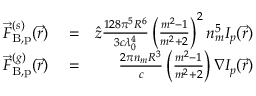<formula> <loc_0><loc_0><loc_500><loc_500>\begin{array} { r l r } { \vec { F } _ { B , p } ^ { ( s ) } ( \vec { r } ) } & = } & { \hat { z } \frac { 1 2 8 \pi ^ { 5 } R ^ { 6 } } { 3 c \lambda _ { 0 } ^ { 4 } } \left ( \frac { m ^ { 2 } - 1 } { m ^ { 2 } + 2 } \right ) ^ { 2 } n _ { m } ^ { 5 } I _ { p } ( \vec { r } ) } \\ { \vec { F } _ { B , p } ^ { ( g ) } ( \vec { r } ) } & = } & { \frac { 2 \pi n _ { m } R ^ { 3 } } { c } \left ( \frac { m ^ { 2 } - 1 } { m ^ { 2 } + 2 } \right ) \nabla I _ { p } ( \vec { r } ) } \end{array}</formula> 